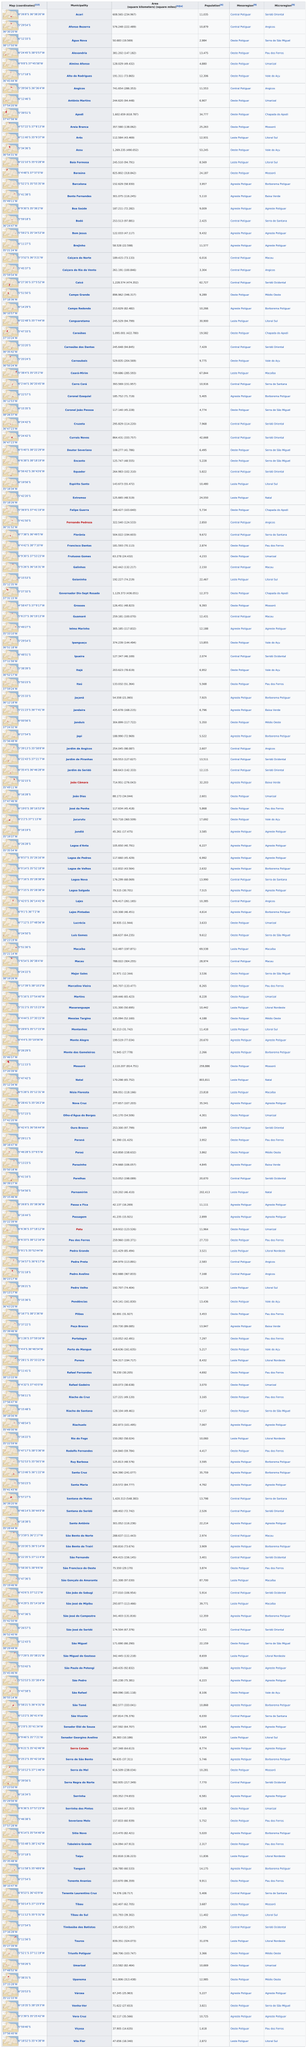Draw attention to some important aspects in this diagram. Viçosa, a municipality with a population of 1,618, is the smallest in terms of population. In alphabetical order, the last municipality is Vila Flor. 